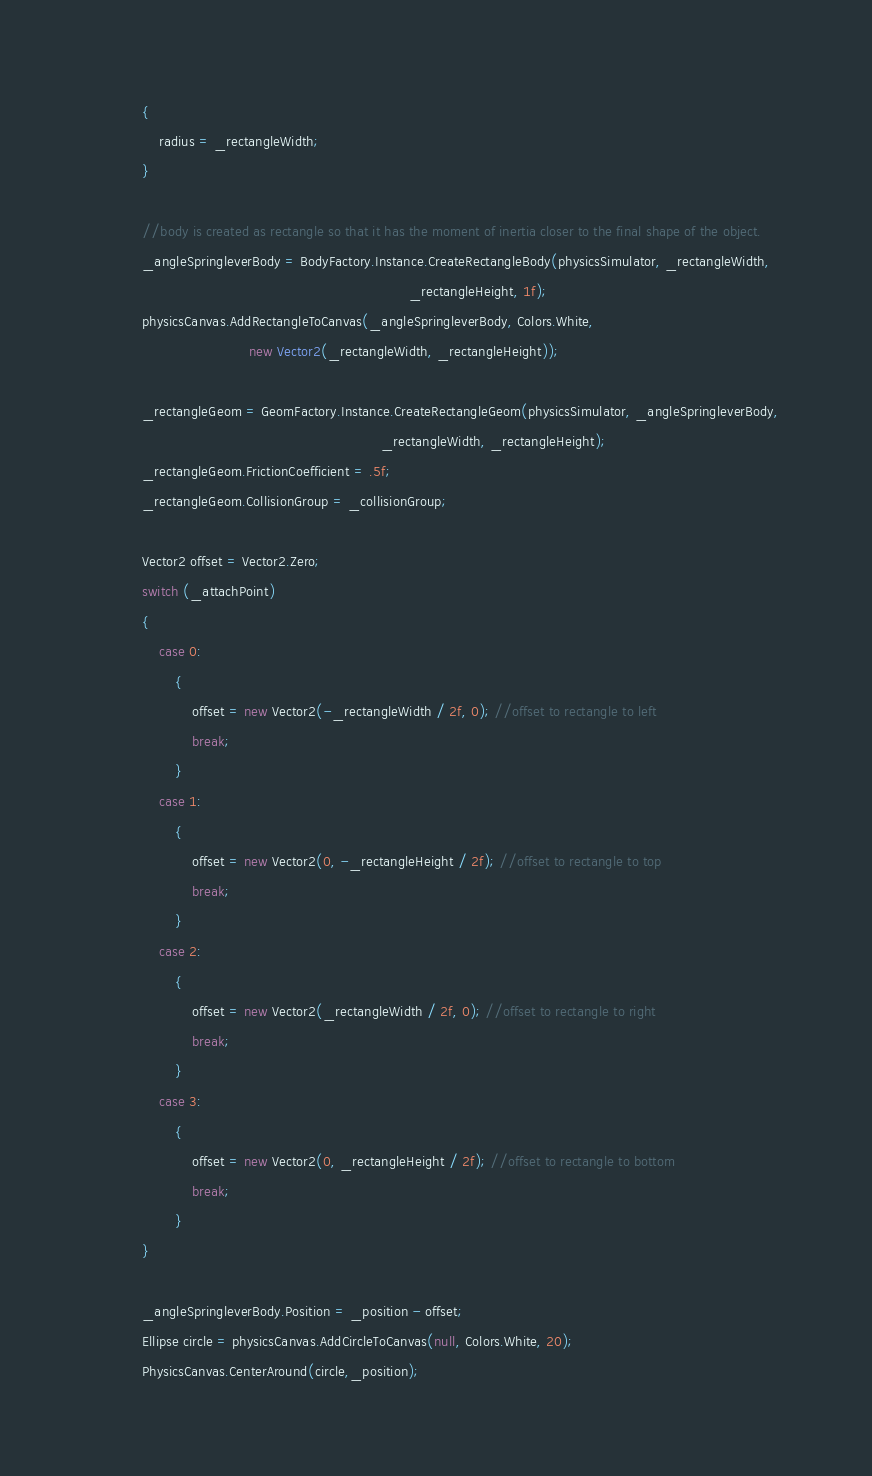Convert code to text. <code><loc_0><loc_0><loc_500><loc_500><_C#_>            {
                radius = _rectangleWidth;
            }

            //body is created as rectangle so that it has the moment of inertia closer to the final shape of the object.
            _angleSpringleverBody = BodyFactory.Instance.CreateRectangleBody(physicsSimulator, _rectangleWidth,
                                                                             _rectangleHeight, 1f);
            physicsCanvas.AddRectangleToCanvas(_angleSpringleverBody, Colors.White,
                                      new Vector2(_rectangleWidth, _rectangleHeight));

            _rectangleGeom = GeomFactory.Instance.CreateRectangleGeom(physicsSimulator, _angleSpringleverBody,
                                                                      _rectangleWidth, _rectangleHeight);
            _rectangleGeom.FrictionCoefficient = .5f;
            _rectangleGeom.CollisionGroup = _collisionGroup;

            Vector2 offset = Vector2.Zero;
            switch (_attachPoint)
            {
                case 0:
                    {
                        offset = new Vector2(-_rectangleWidth / 2f, 0); //offset to rectangle to left
                        break;
                    }
                case 1:
                    {
                        offset = new Vector2(0, -_rectangleHeight / 2f); //offset to rectangle to top
                        break;
                    }
                case 2:
                    {
                        offset = new Vector2(_rectangleWidth / 2f, 0); //offset to rectangle to right
                        break;
                    }
                case 3:
                    {
                        offset = new Vector2(0, _rectangleHeight / 2f); //offset to rectangle to bottom
                        break;
                    }
            }

            _angleSpringleverBody.Position = _position - offset;
            Ellipse circle = physicsCanvas.AddCircleToCanvas(null, Colors.White, 20);
            PhysicsCanvas.CenterAround(circle,_position);</code> 